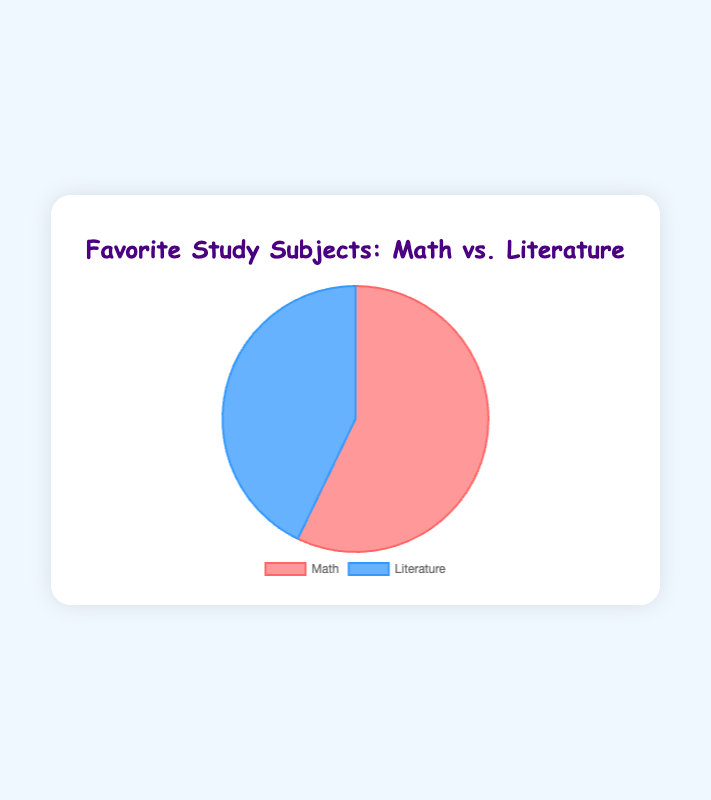What percentage of time was spent on Math versus Literature? The pie chart shows two segments representing the time spent on Math and Literature. The sum of the time spent on both subjects is 8 + 6 = 14 hours per week. The percentage for Math is (8/14) * 100 ≈ 57.14%, and the percentage for Literature is (6/14) * 100 ≈ 42.86%.
Answer: Math: 57.14%, Literature: 42.86% Which subject received more time investment? By looking at the chart, we can see that the Math segment is larger than the Literature segment. Math has 8 hours per week compared to Literature’s 6 hours per week.
Answer: Math What is the ratio of time spent on Math to Literature? The time spent on Math is 8 hours per week, and for Literature, it is 6 hours per week. The ratio of Math to Literature is 8:6, which simplifies to 4:3.
Answer: 4:3 How many more hours per week are spent on Math than Literature? Comparing the hours spent, Math has 8 hours per week and Literature has 6 hours per week. The difference is 8 - 6 = 2 hours per week.
Answer: 2 hours per week If one hour is moved from Math to Literature, what will the new percentages be? Initially, Math has 8 hours, and Literature has 6 hours. Moving 1 hour from Math to Literature changes the values to 7 hours for Math, and 7 hours for Literature. The total hours remain 14. The new percentages are (7/14) * 100 = 50% for both subjects.
Answer: Math: 50%, Literature: 50% Which segment is visually larger, and what does it represent? The visually larger segment is the one colored corresponding to Math. It represents more time (8 hours per week) spent on Math compared to Literature.
Answer: Math segment If the total time available for both subjects increases by 2 hours per week, how will the time distribution change while maintaining the same ratio? Current total time is 14 hours. If 2 hours are added, the new total is 16 hours. The ratio of Math to Literature is 4:3. For an increase, using the same ratio, Math will have (4/7) * 16 ≈ 9.14 hours, and Literature will have (3/7) * 16 ≈ 6.86 hours.
Answer: Math: 9.14 hours, Literature: 6.86 hours What are the primary colors used in the pie chart, and which subjects do they correspond to? The primary colors used are red and blue. The red color corresponds to Math, and the blue color corresponds to Literature.
Answer: Red: Math, Blue: Literature 